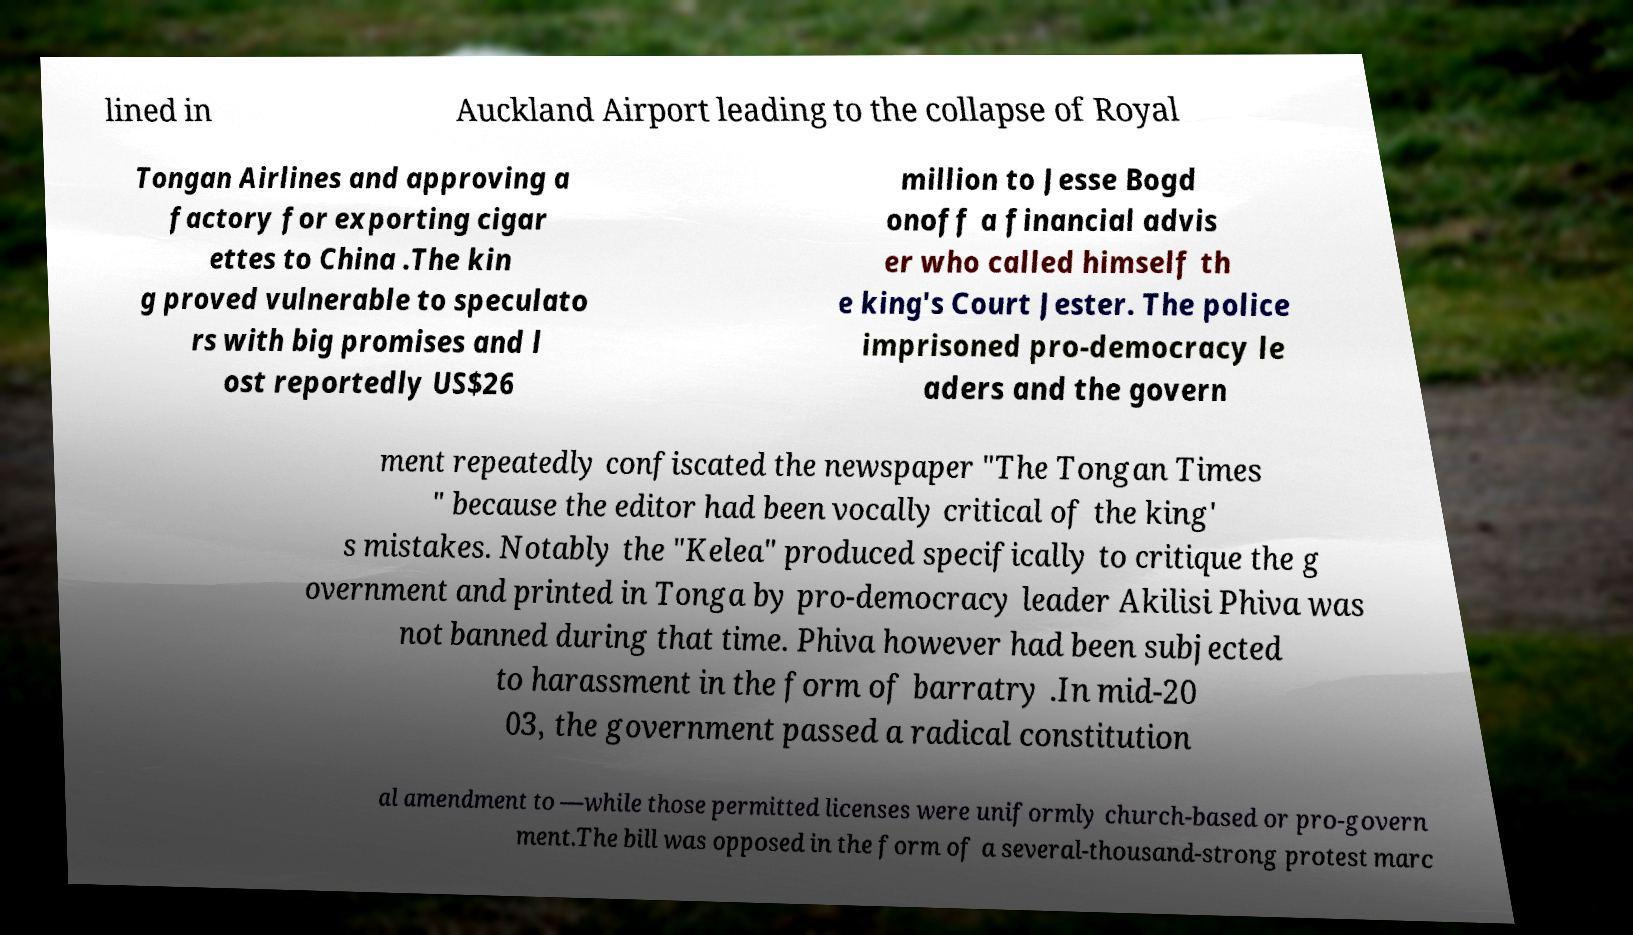Could you extract and type out the text from this image? lined in Auckland Airport leading to the collapse of Royal Tongan Airlines and approving a factory for exporting cigar ettes to China .The kin g proved vulnerable to speculato rs with big promises and l ost reportedly US$26 million to Jesse Bogd onoff a financial advis er who called himself th e king's Court Jester. The police imprisoned pro-democracy le aders and the govern ment repeatedly confiscated the newspaper "The Tongan Times " because the editor had been vocally critical of the king' s mistakes. Notably the "Kelea" produced specifically to critique the g overnment and printed in Tonga by pro-democracy leader Akilisi Phiva was not banned during that time. Phiva however had been subjected to harassment in the form of barratry .In mid-20 03, the government passed a radical constitution al amendment to —while those permitted licenses were uniformly church-based or pro-govern ment.The bill was opposed in the form of a several-thousand-strong protest marc 